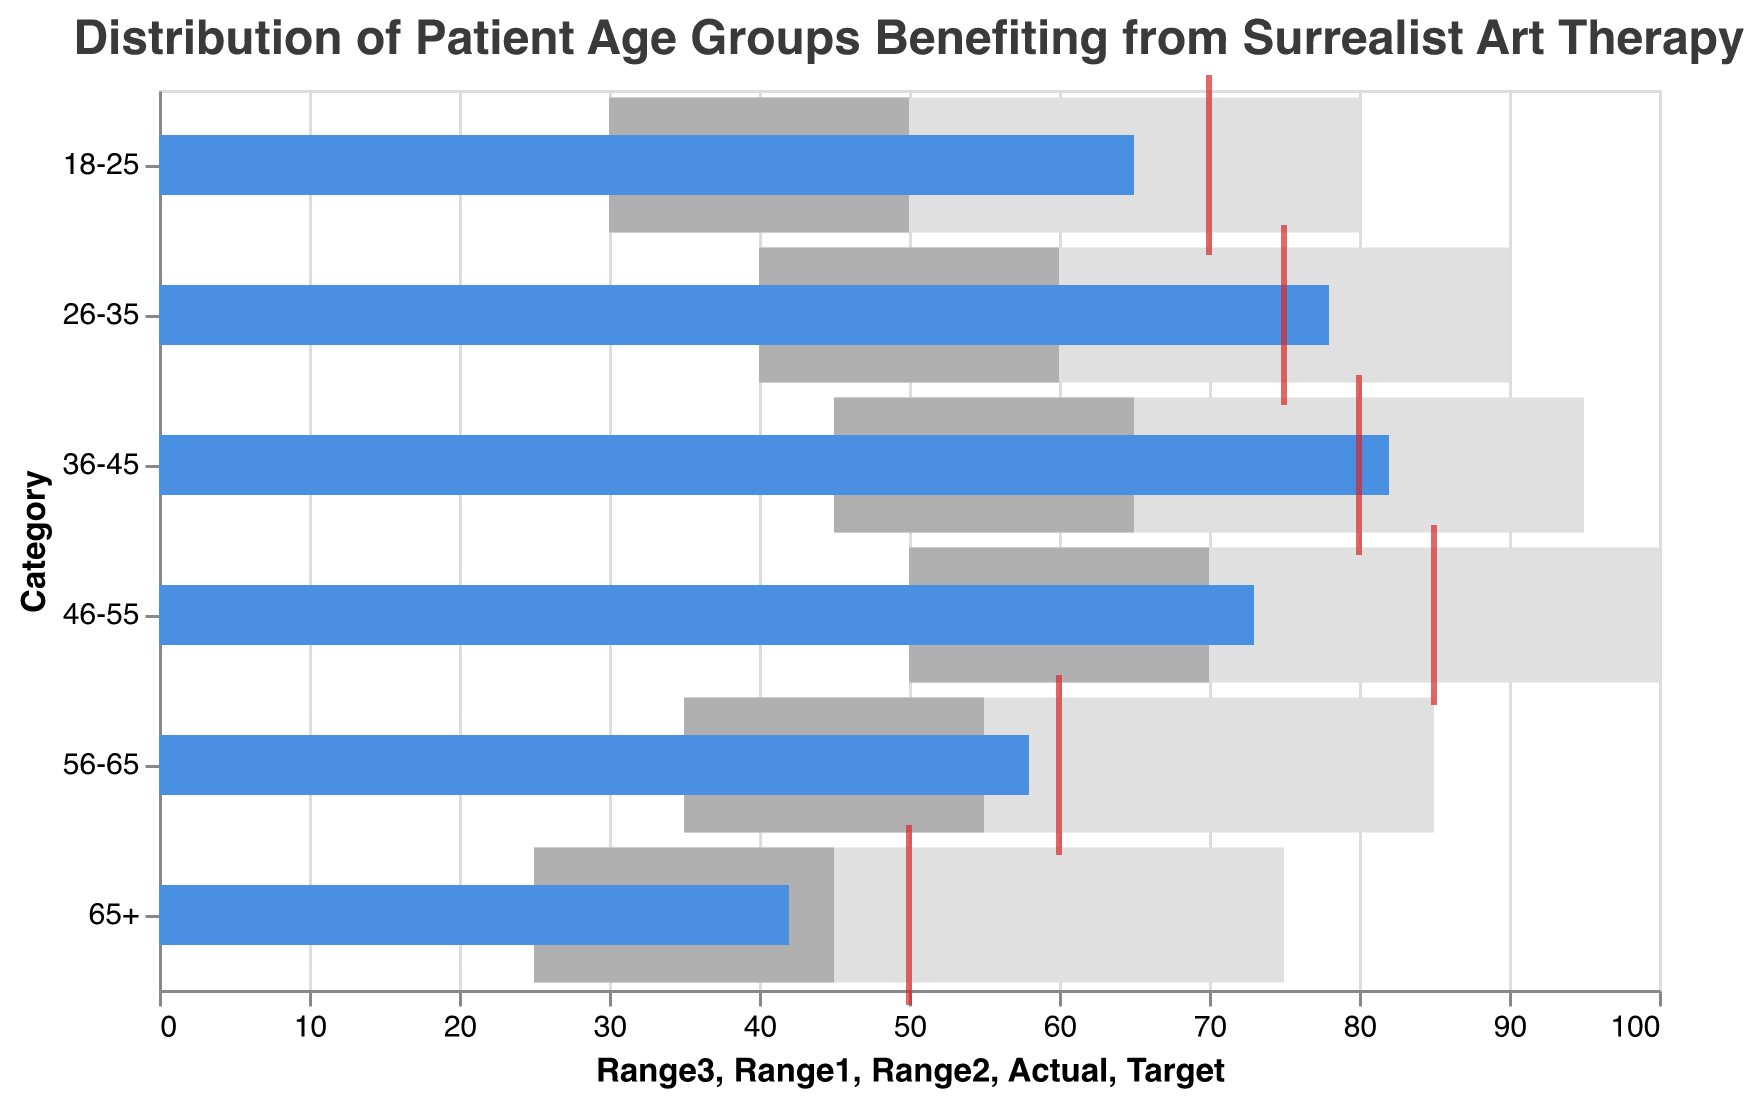What is the title of the figure? The title of a figure is usually provided to give an overall context or summary of what the figure is about. In this case, it is located at the top of the visualization.
Answer: Distribution of Patient Age Groups Benefiting from Surrealist Art Therapy Which age group has the highest actual value? To determine the age group with the highest actual value, look for the bar that extends the farthest to the right within the color-coded bars representing actual values.
Answer: 36-45 What is the actual value for the 56-65 age group? Identify the color-coded bar representing the actual value for the 56-65 age group and read its value along the x-axis.
Answer: 58 How does the actual value for the 18-25 group compare to its target value? Compare the length of the bar representing the actual value for the 18-25 age group with the tick mark denoting the target value on the x-axis.
Answer: The actual value is 5 units less than the target value Which age group fell short of their target value by the largest margin? Calculate the difference between the actual and target values for each age group, then identify which has the largest shortfall.
Answer: 46-55 Which age group has the most substantial benefit from surrealist art therapy based on actual values? Determine this by looking at the actual value bars and identifying the longest one, indicating the highest number of patients benefiting.
Answer: 36-45 What are the three ranges for the 26-35 age group? Check the endpoints of the three range bars for the 26-35 age group.
Answer: 40, 60, and 90 How far is the actual value from the upper boundary of Range3 for the 65+ age group? Subtract the actual value from the upper boundary of Range3 for the 65+ age group.
Answer: 33 Which age group has their actual value closest to the upper boundary of their Range2? Identify the age group where the difference between the actual value and the upper boundary of Range2 is the smallest by visually inspecting the figure or performing the calculations.
Answer: 56-65 Are there any age groups where the actual value exceeds their target? Examine each age group's actual value bar and see if it goes beyond the target tick mark.
Answer: Yes, 26-35 and 36-45 